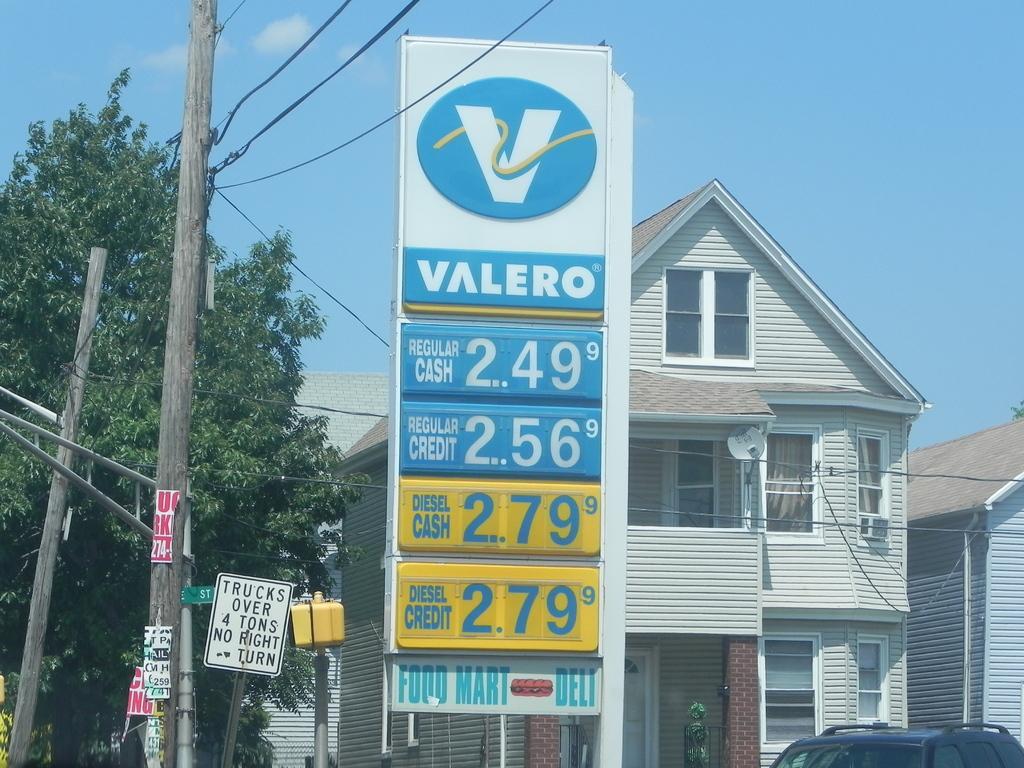Describe this image in one or two sentences. In this picture we can see buildings in the background, there are some boards in the front, we can see poles on the left side, at the right bottom there is a car, we can see tree, there is the sky at the top of the picture. 